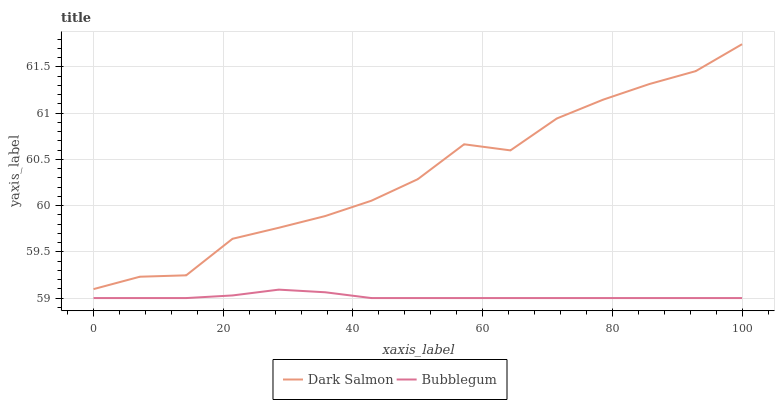Does Bubblegum have the minimum area under the curve?
Answer yes or no. Yes. Does Dark Salmon have the maximum area under the curve?
Answer yes or no. Yes. Does Bubblegum have the maximum area under the curve?
Answer yes or no. No. Is Bubblegum the smoothest?
Answer yes or no. Yes. Is Dark Salmon the roughest?
Answer yes or no. Yes. Is Bubblegum the roughest?
Answer yes or no. No. Does Bubblegum have the lowest value?
Answer yes or no. Yes. Does Dark Salmon have the highest value?
Answer yes or no. Yes. Does Bubblegum have the highest value?
Answer yes or no. No. Is Bubblegum less than Dark Salmon?
Answer yes or no. Yes. Is Dark Salmon greater than Bubblegum?
Answer yes or no. Yes. Does Bubblegum intersect Dark Salmon?
Answer yes or no. No. 